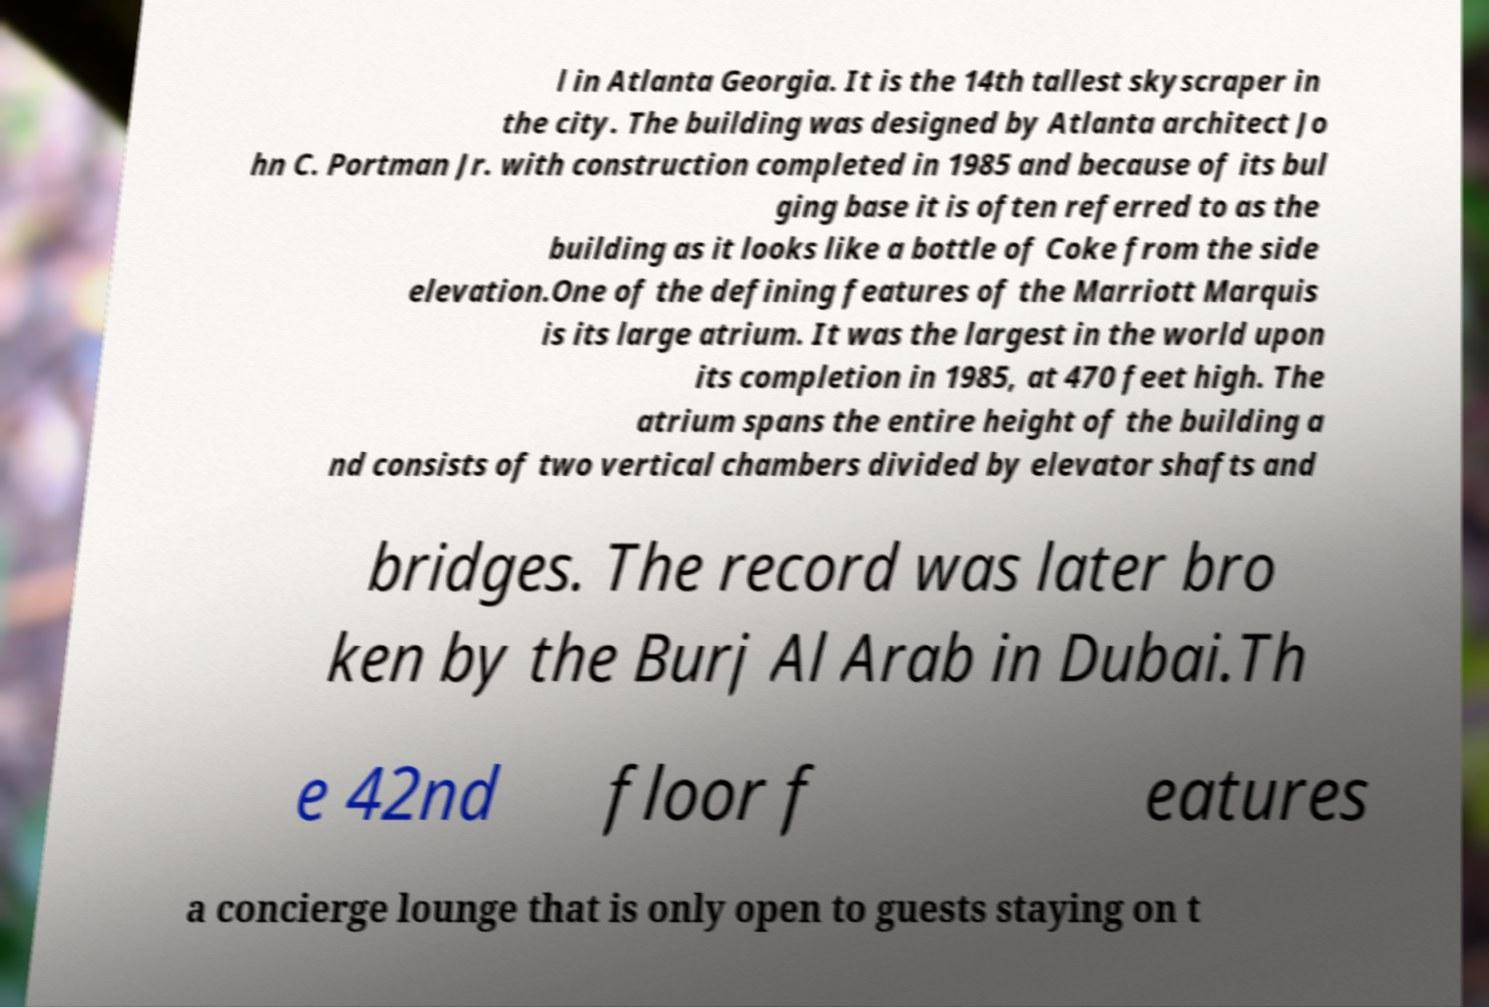Please identify and transcribe the text found in this image. l in Atlanta Georgia. It is the 14th tallest skyscraper in the city. The building was designed by Atlanta architect Jo hn C. Portman Jr. with construction completed in 1985 and because of its bul ging base it is often referred to as the building as it looks like a bottle of Coke from the side elevation.One of the defining features of the Marriott Marquis is its large atrium. It was the largest in the world upon its completion in 1985, at 470 feet high. The atrium spans the entire height of the building a nd consists of two vertical chambers divided by elevator shafts and bridges. The record was later bro ken by the Burj Al Arab in Dubai.Th e 42nd floor f eatures a concierge lounge that is only open to guests staying on t 